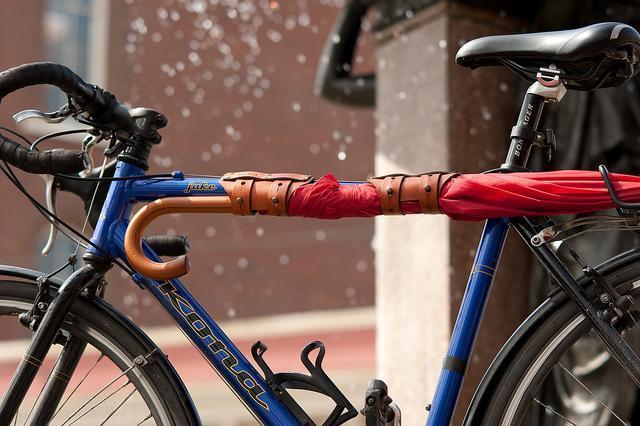Does the image validate the caption "The umbrella is attached to the bicycle."?
Answer yes or no. Yes. 